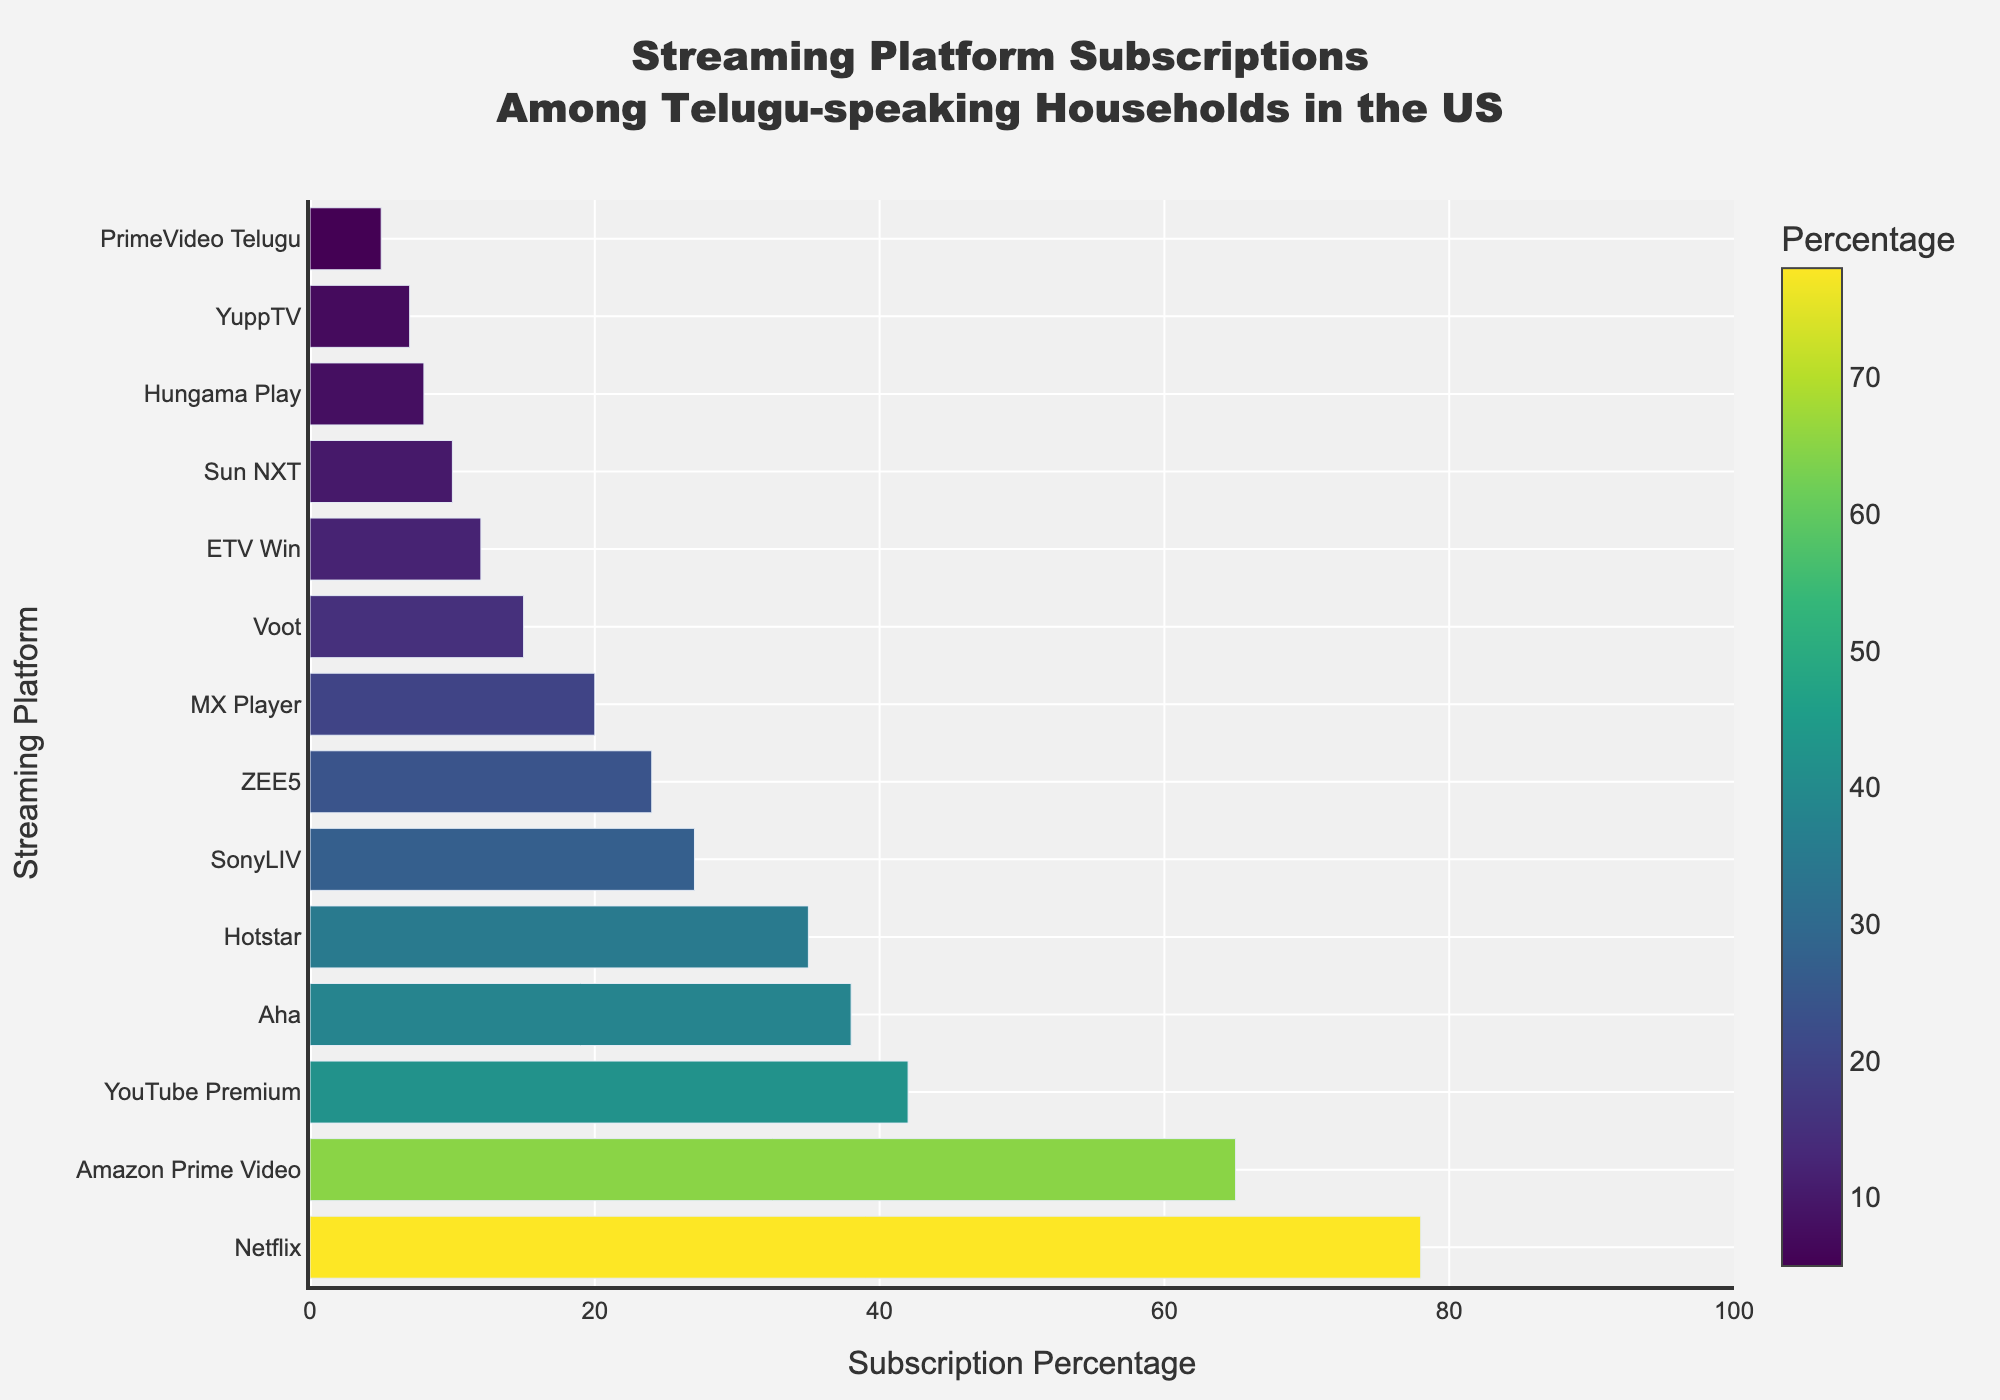Which platform has the highest subscription percentage among Telugu-speaking households in the US? The tallest bar in the chart corresponds to Netflix, indicating it has the highest subscription percentage.
Answer: Netflix By how much does the subscription percentage of Amazon Prime Video exceed that of Aha? Amazon Prime Video has a subscription percentage of 65%, while Aha has 38%. Subtract Aha's percentage from Amazon Prime Video's percentage: 65 - 38.
Answer: 27 What's the third most subscribed streaming platform? The bar chart shows the subscription percentages in descending order. The third bar from the top corresponds to YouTube Premium.
Answer: YouTube Premium How many platforms have a subscription percentage greater than 30%? Identify the bars with percentages more than 30. The platforms are Netflix, Amazon Prime Video, YouTube Premium, Aha, and Hotstar.
Answer: 5 What is the combined subscription percentage of SonyLIV and ZEE5? SonyLIV has a subscription percentage of 27% and ZEE5 has 24%. Add these percentages to get the total: 27 + 24.
Answer: 51 Which platform has the lowest subscription percentage? The shortest bar on the chart corresponds to PrimeVideo Telugu, indicating it has the lowest subscription percentage.
Answer: PrimeVideo Telugu Which platform has a subscription percentage closest to 50%? Identify the bar closest to the 50% mark. None match exactly, but YouTube Premium at 42% is the closest.
Answer: YouTube Premium Are there more platforms with a subscription percentage below 20% or above 20%? Count the platforms: 1) Below 20%: MX Player, Voot, ETV Win, Sun NXT, Hungama Play, YuppTV, PrimeVideo Telugu (total: 7). 2) Above 20%: Netflix, Amazon Prime Video, YouTube Premium, Aha, Hotstar, SonyLIV, ZEE5 (total: 7).
Answer: Equal What percentage does Aha contribute relative to Netflix in terms of subscriptions? Aha's subscription percentage is 38%, and Netflix's is 78%. To find the relative percentage contribution: (38 / 78) * 100%.
Answer: Approximately 48.7% Which colors represent the platforms with the second and fourth highest subscription percentages? The second highest is Amazon Prime Video (65%) shown in a lighter color due to the color scale, and the fourth highest is Aha (38%) shown in a moderately dark color on the Viridis scale.
Answer: Light color, moderately dark color 